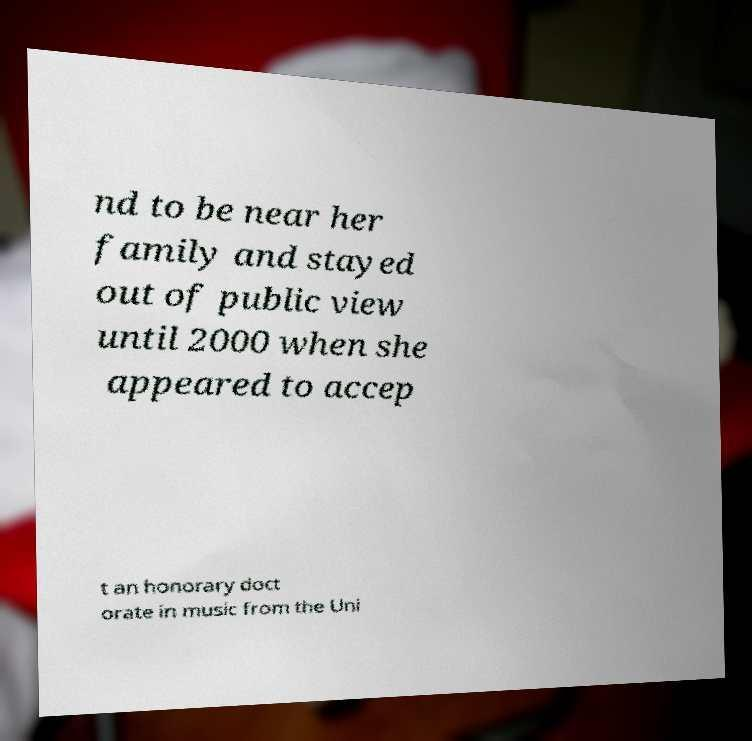Can you accurately transcribe the text from the provided image for me? nd to be near her family and stayed out of public view until 2000 when she appeared to accep t an honorary doct orate in music from the Uni 